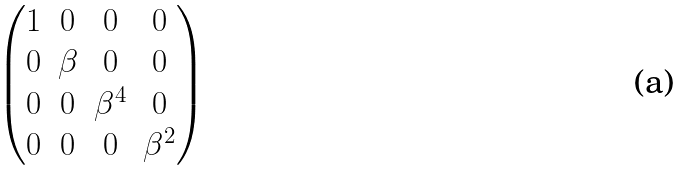<formula> <loc_0><loc_0><loc_500><loc_500>\begin{pmatrix} 1 & 0 & 0 & 0 \\ 0 & \beta & 0 & 0 \\ 0 & 0 & { \beta } ^ { 4 } & 0 \\ 0 & 0 & 0 & { \beta } ^ { 2 } \end{pmatrix}</formula> 